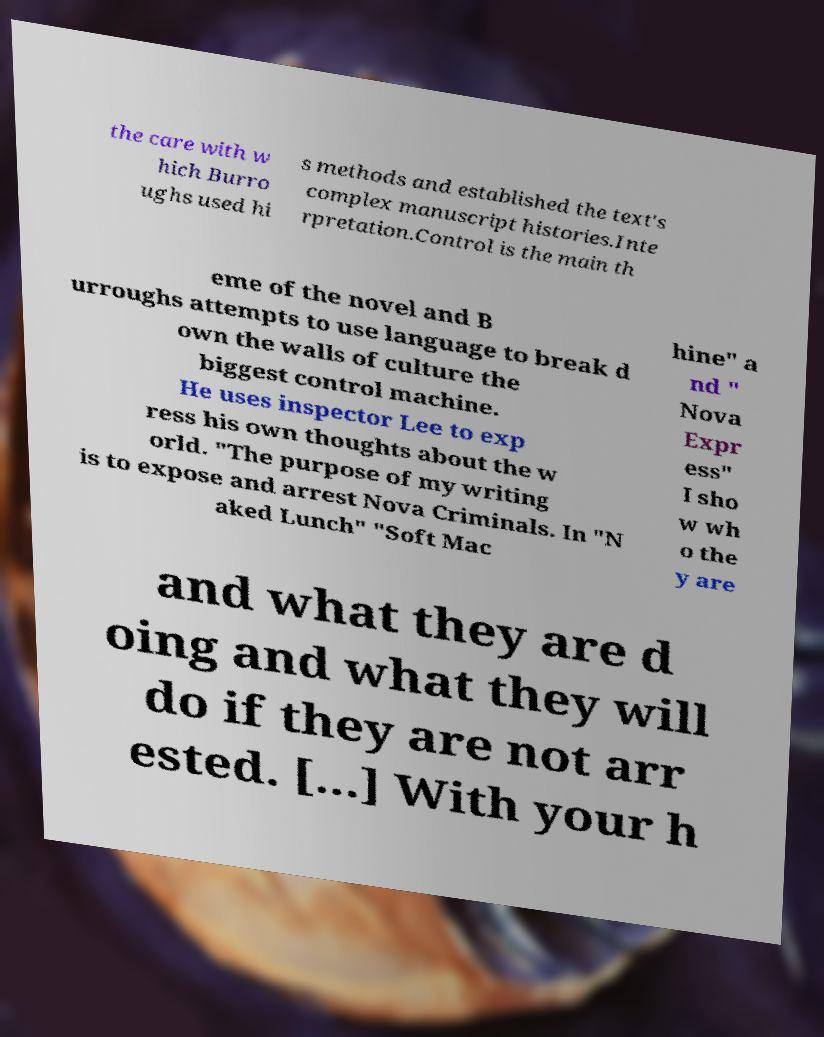I need the written content from this picture converted into text. Can you do that? the care with w hich Burro ughs used hi s methods and established the text's complex manuscript histories.Inte rpretation.Control is the main th eme of the novel and B urroughs attempts to use language to break d own the walls of culture the biggest control machine. He uses inspector Lee to exp ress his own thoughts about the w orld. "The purpose of my writing is to expose and arrest Nova Criminals. In "N aked Lunch" "Soft Mac hine" a nd " Nova Expr ess" I sho w wh o the y are and what they are d oing and what they will do if they are not arr ested. [...] With your h 